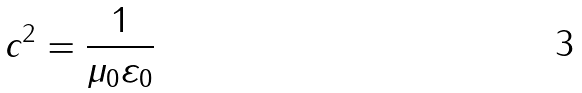Convert formula to latex. <formula><loc_0><loc_0><loc_500><loc_500>c ^ { 2 } = { \frac { 1 } { \mu _ { 0 } \varepsilon _ { 0 } } }</formula> 